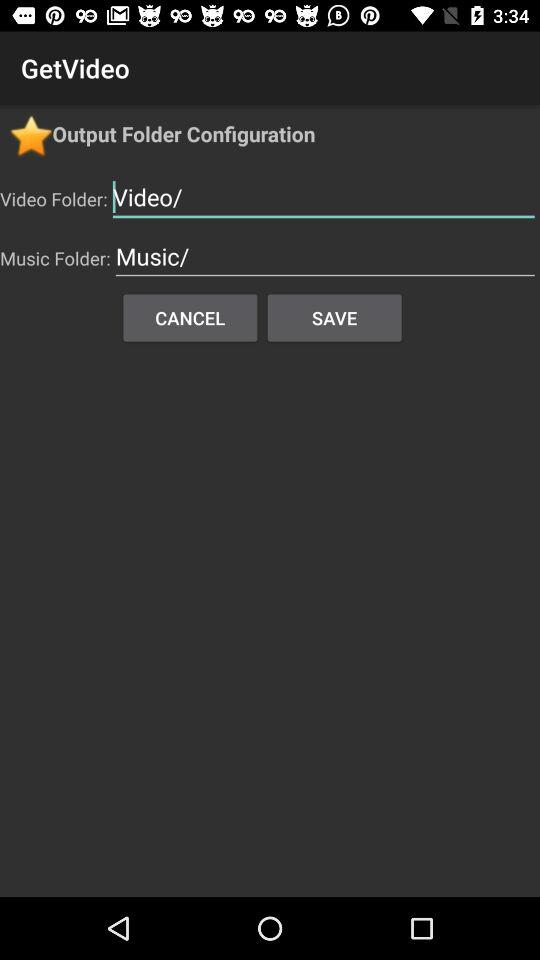Could you explain the significance of the star icon at the top of the app? The star icon in the 'GetVideo' app likely denotes a feature for favoriting or highlighting important folders or settings. Users may use it to mark frequently accessed or preferred configurations for quick access. 